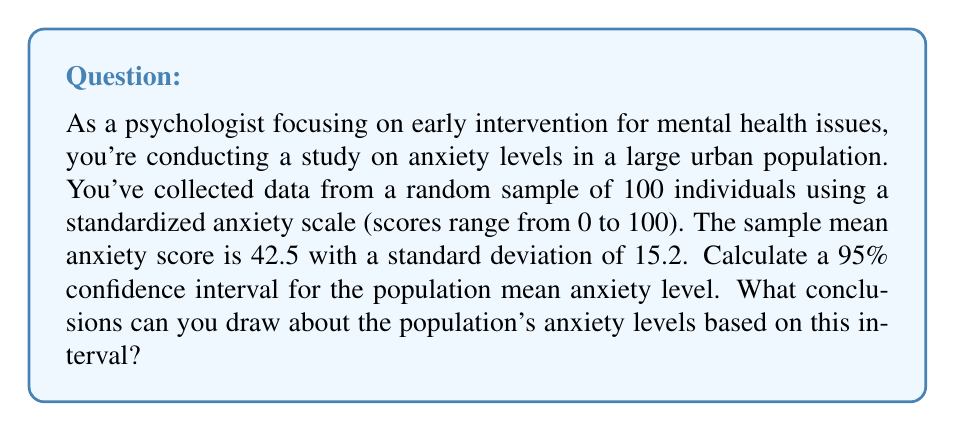Help me with this question. To calculate the confidence interval for the population mean, we'll use the formula:

$$ \text{CI} = \bar{x} \pm t_{\alpha/2} \cdot \frac{s}{\sqrt{n}} $$

Where:
- $\bar{x}$ is the sample mean (42.5)
- $s$ is the sample standard deviation (15.2)
- $n$ is the sample size (100)
- $t_{\alpha/2}$ is the t-value for a 95% confidence level with 99 degrees of freedom

Steps:
1) Degrees of freedom (df) = n - 1 = 100 - 1 = 99
2) For a 95% confidence level and df = 99, $t_{\alpha/2} \approx 1.984$ (from t-distribution table)
3) Calculate the margin of error:
   $$ \text{ME} = t_{\alpha/2} \cdot \frac{s}{\sqrt{n}} = 1.984 \cdot \frac{15.2}{\sqrt{100}} = 1.984 \cdot 1.52 = 3.016 $$
4) Calculate the confidence interval:
   $$ \text{CI} = 42.5 \pm 3.016 = (39.484, 45.516) $$

Conclusion: We can be 95% confident that the true population mean anxiety level falls between 39.484 and 45.516 on the standardized anxiety scale. This suggests that the average anxiety level in the population is moderate, as it falls below the midpoint of the scale (50). However, it's high enough to warrant attention for early intervention strategies.
Answer: 95% CI: (39.484, 45.516); Moderate population anxiety level, justifying early intervention. 